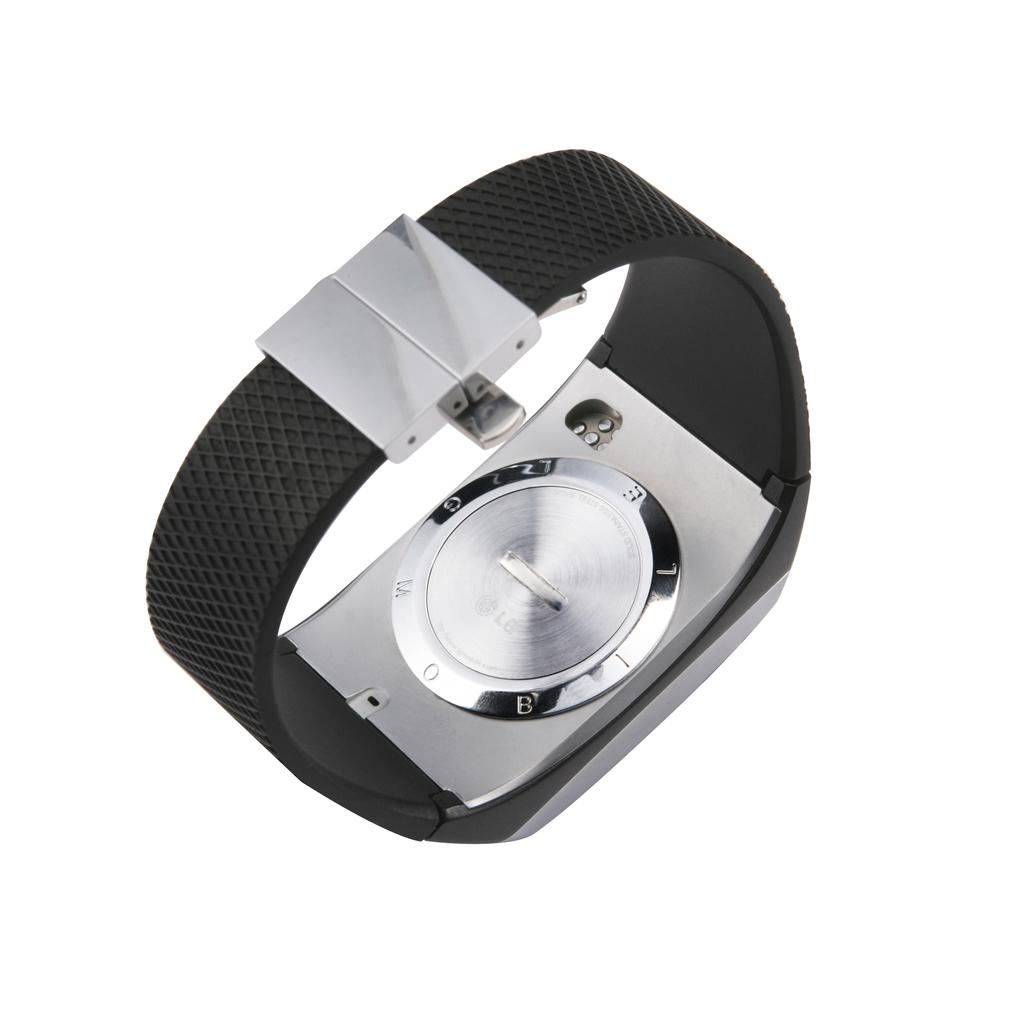What type of accessory is present in the image? There is a wrist watch in the image. What color is the strap of the wrist watch? The strap of the wrist watch is black. What part of the wrist watch is visible in the image? The case cover of the wrist watch is visible. What color is the background of the image? The background of the image is white. What type of stamp can be seen on the wrist watch in the image? There is no stamp present on the wrist watch in the image. 